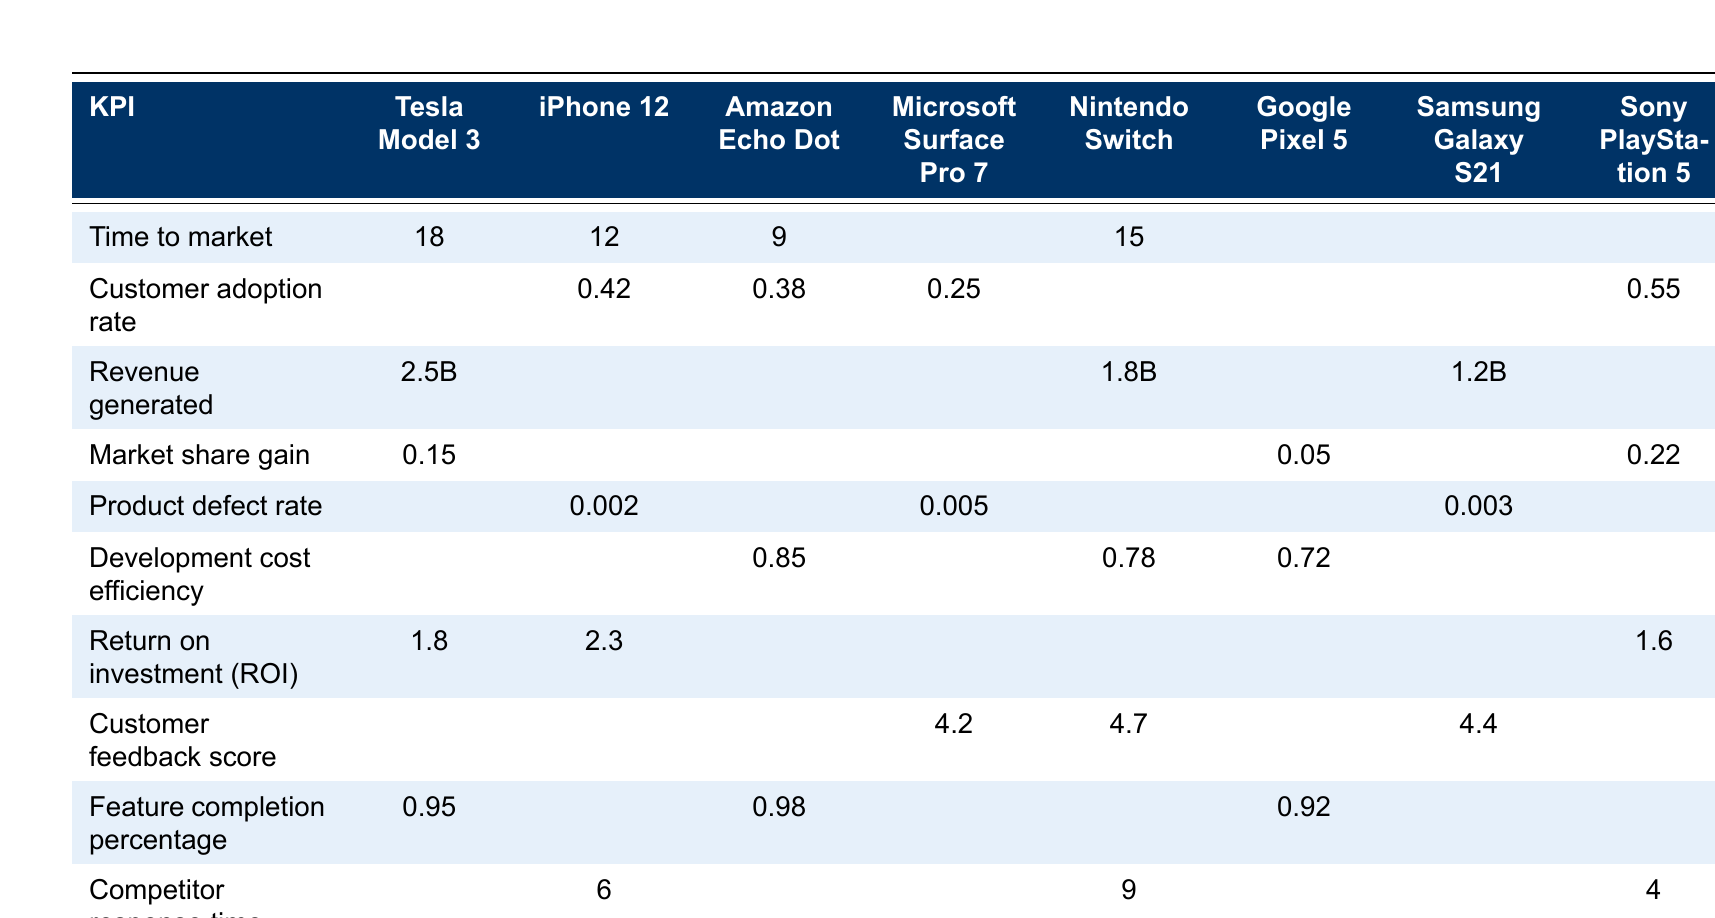What is the time to market for the Amazon Echo Dot? The table shows the time to market for the Amazon Echo Dot is listed as 9 months.
Answer: 9 months Which product has the highest customer adoption rate? The customer adoption rates show that the Sony PlayStation 5 has the highest rate at 0.55.
Answer: Sony PlayStation 5 What is the revenue generated by the Tesla Model 3? According to the table, the Tesla Model 3 generated a revenue of 2.5 billion dollars.
Answer: 2.5 billion dollars What is the product defect rate of the Samsung Galaxy S21? The product defect rate for the Samsung Galaxy S21 is noted as 0.003.
Answer: 0.003 Which product has the highest return on investment (ROI)? The return on investment (ROI) shows that the iPhone 12 has the highest ROI at 2.3.
Answer: iPhone 12 Calculate the average time to market of the products listed. The time to market values are 18, 12, 9, and 15 months (for the four listed); the total is 54 months, and divided by 4 gives an average of 13.5 months.
Answer: 13.5 months Is the customer feedback score for the Microsoft Surface Pro 7 higher than that for the Nintendo Switch? The customer feedback score for Microsoft Surface Pro 7 is 4.2, which is lower than the 4.7 for Nintendo Switch, making the statement false.
Answer: No What is the overall development cost efficiency for the listed products? The development cost efficiencies for listed products are 0.85, 0.78, and 0.72 (for the three specified); averaging them gives (0.85 + 0.78 + 0.72) / 3 = 0.783.
Answer: 0.783 Which product took the longest time to market among the listed? The longest time to market is 18 months, which corresponds to the Tesla Model 3.
Answer: Tesla Model 3 What percentage of features were completed for the Google Pixel 5? The features completion percentage for the Google Pixel 5 is 0.92, indicating 92% completion.
Answer: 92% 